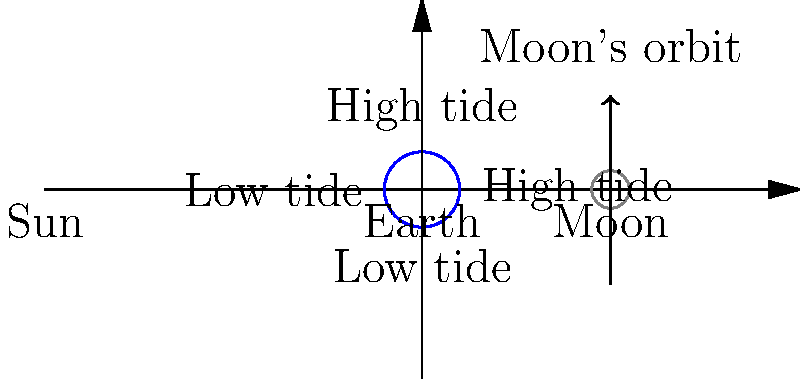In the diagram above, which represents the Earth-Moon system, how does the phase of the Moon affect the strength of the tides on Earth? Consider the biological implications of this phenomenon for intertidal ecosystems. To understand the relationship between Moon phases and tidal strength, and its biological implications, let's follow these steps:

1. Moon phases and alignment:
   - New Moon: Sun and Moon aligned on the same side of Earth
   - Full Moon: Sun and Earth aligned on opposite sides of the Moon

2. Gravitational forces:
   - The Moon's gravity is the primary cause of tides on Earth
   - The Sun's gravity also contributes, but to a lesser extent

3. Spring tides:
   - Occur during New Moon and Full Moon
   - Sun, Moon, and Earth align, causing their gravitational forces to combine
   - Result in higher high tides and lower low tides

4. Neap tides:
   - Occur during First Quarter and Third Quarter Moon phases
   - Sun and Moon are at right angles to Earth
   - Their gravitational forces partially cancel out
   - Result in lower high tides and higher low tides

5. Tidal range:
   - Spring tides: Largest tidal range
   - Neap tides: Smallest tidal range

6. Biological implications for intertidal ecosystems:
   a. Zonation:
      - Organisms distribute themselves based on their ability to withstand exposure
      - Spring tides expose more of the intertidal zone, affecting species distribution

   b. Adaptations:
      - Organisms develop strategies to cope with varying periods of exposure
      - Examples: shell closure in mollusks, water retention in seaweeds

   c. Nutrient cycling:
      - Stronger tides during spring tides increase nutrient mixing
      - Enhances productivity in intertidal and nearby ecosystems

   d. Reproduction and larval dispersal:
      - Many species synchronize spawning with spring tides for maximum dispersal
      - Affects genetic diversity and population connectivity

   e. Predator-prey interactions:
      - Tidal changes influence feeding opportunities and predation risks
      - Affects behavior and community structure

By understanding these connections, educators can integrate space physics concepts into biology curricula, demonstrating the interconnectedness of Earth and space systems and their impact on biological processes.
Answer: Spring tides (New/Full Moon) cause stronger tides, while neap tides (First/Third Quarter) cause weaker tides, significantly impacting intertidal ecosystem zonation, adaptations, nutrient cycling, reproduction, and species interactions. 